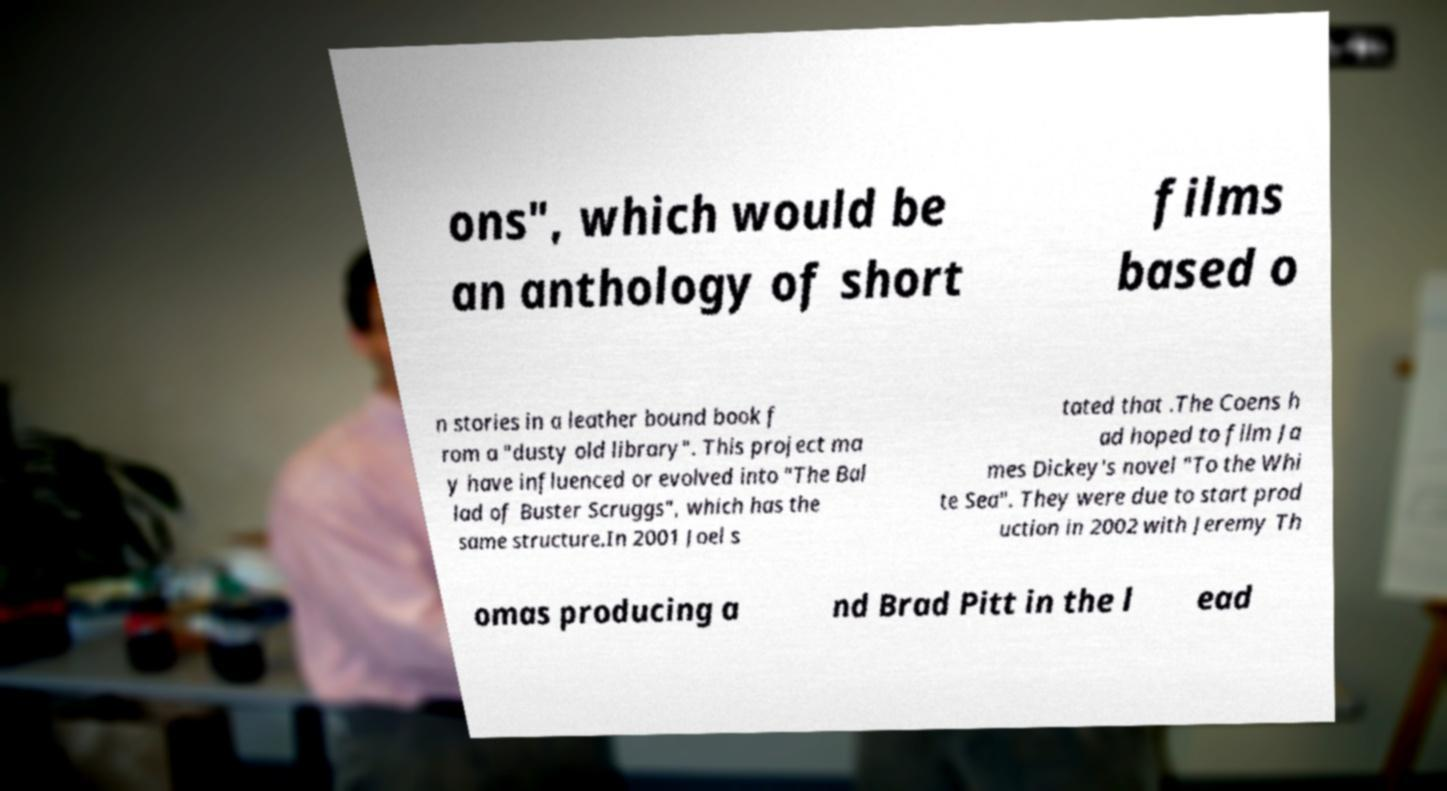Please identify and transcribe the text found in this image. ons", which would be an anthology of short films based o n stories in a leather bound book f rom a "dusty old library". This project ma y have influenced or evolved into "The Bal lad of Buster Scruggs", which has the same structure.In 2001 Joel s tated that .The Coens h ad hoped to film Ja mes Dickey's novel "To the Whi te Sea". They were due to start prod uction in 2002 with Jeremy Th omas producing a nd Brad Pitt in the l ead 